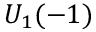Convert formula to latex. <formula><loc_0><loc_0><loc_500><loc_500>U _ { 1 } ( - 1 )</formula> 